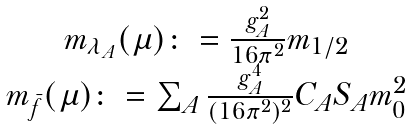Convert formula to latex. <formula><loc_0><loc_0><loc_500><loc_500>\begin{array} { c } m _ { \lambda _ { A } } ( \mu ) \colon = \frac { g ^ { 2 } _ { A } } { 1 6 \pi ^ { 2 } } m _ { 1 / 2 } \\ m _ { \bar { f } } ( \mu ) \colon = \sum _ { A } \frac { g ^ { 4 } _ { A } } { ( 1 6 \pi ^ { 2 } ) ^ { 2 } } C _ { A } S _ { A } m _ { 0 } ^ { 2 } \\ \end{array}</formula> 